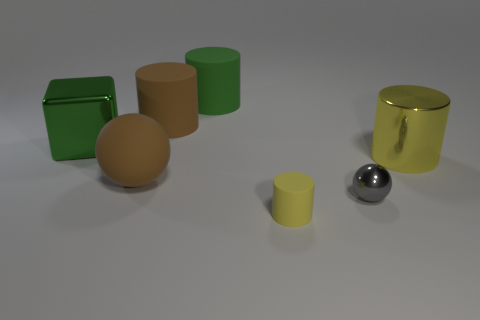Subtract all gray cylinders. Subtract all red blocks. How many cylinders are left? 4 Add 2 brown matte spheres. How many objects exist? 9 Subtract all cylinders. How many objects are left? 3 Add 5 purple things. How many purple things exist? 5 Subtract 0 cyan cylinders. How many objects are left? 7 Subtract all brown matte spheres. Subtract all green cylinders. How many objects are left? 5 Add 6 gray shiny things. How many gray shiny things are left? 7 